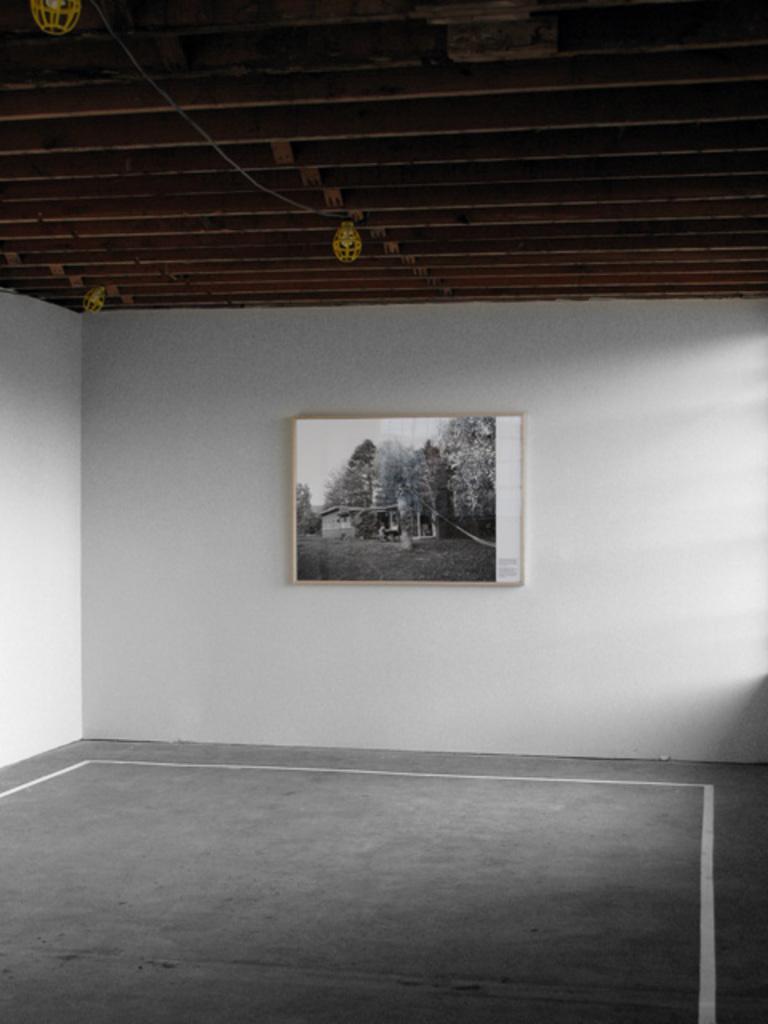Describe this image in one or two sentences. In this picture we can see the floor, roof, photo frame on the wall and some objects. 